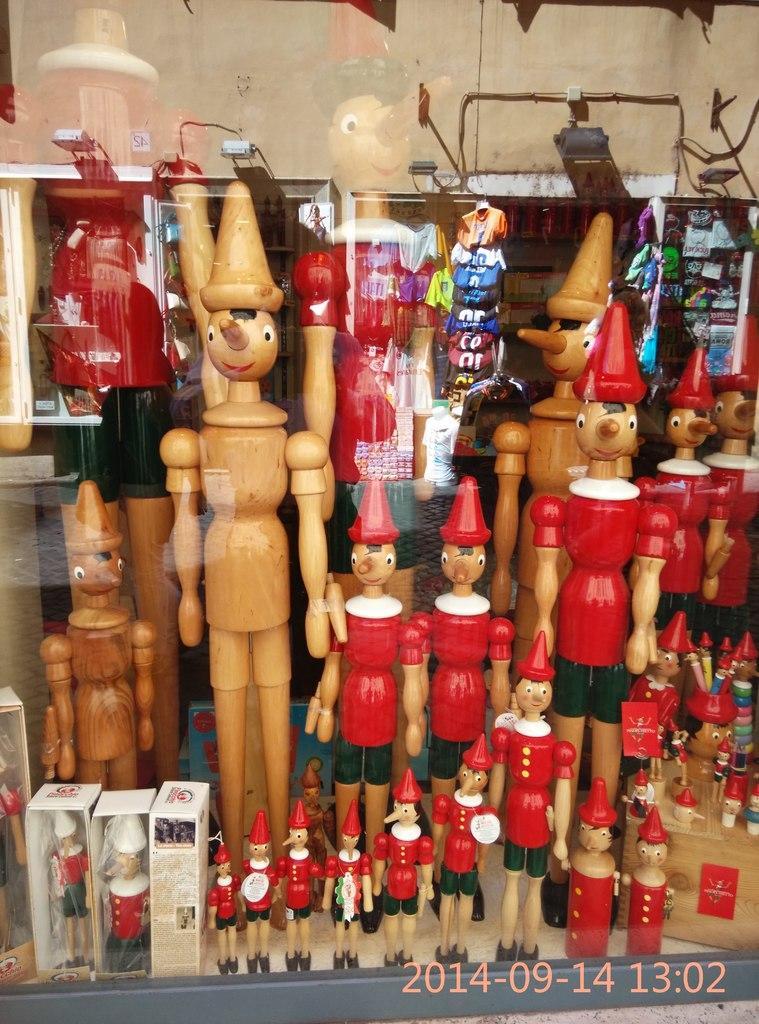Can you describe this image briefly? In this picture there is a glass window. On the other side of the window there are toys and boxes. At the top it is well. 